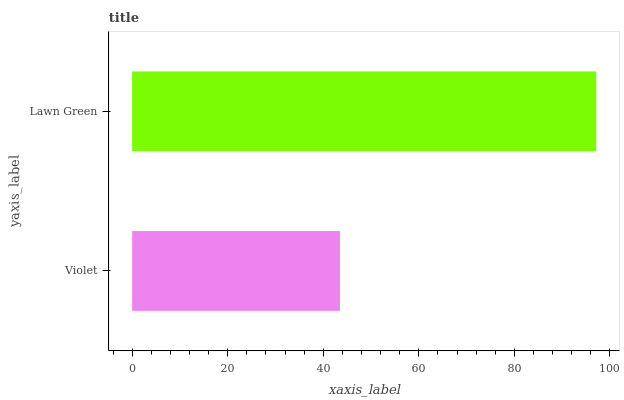Is Violet the minimum?
Answer yes or no. Yes. Is Lawn Green the maximum?
Answer yes or no. Yes. Is Lawn Green the minimum?
Answer yes or no. No. Is Lawn Green greater than Violet?
Answer yes or no. Yes. Is Violet less than Lawn Green?
Answer yes or no. Yes. Is Violet greater than Lawn Green?
Answer yes or no. No. Is Lawn Green less than Violet?
Answer yes or no. No. Is Lawn Green the high median?
Answer yes or no. Yes. Is Violet the low median?
Answer yes or no. Yes. Is Violet the high median?
Answer yes or no. No. Is Lawn Green the low median?
Answer yes or no. No. 